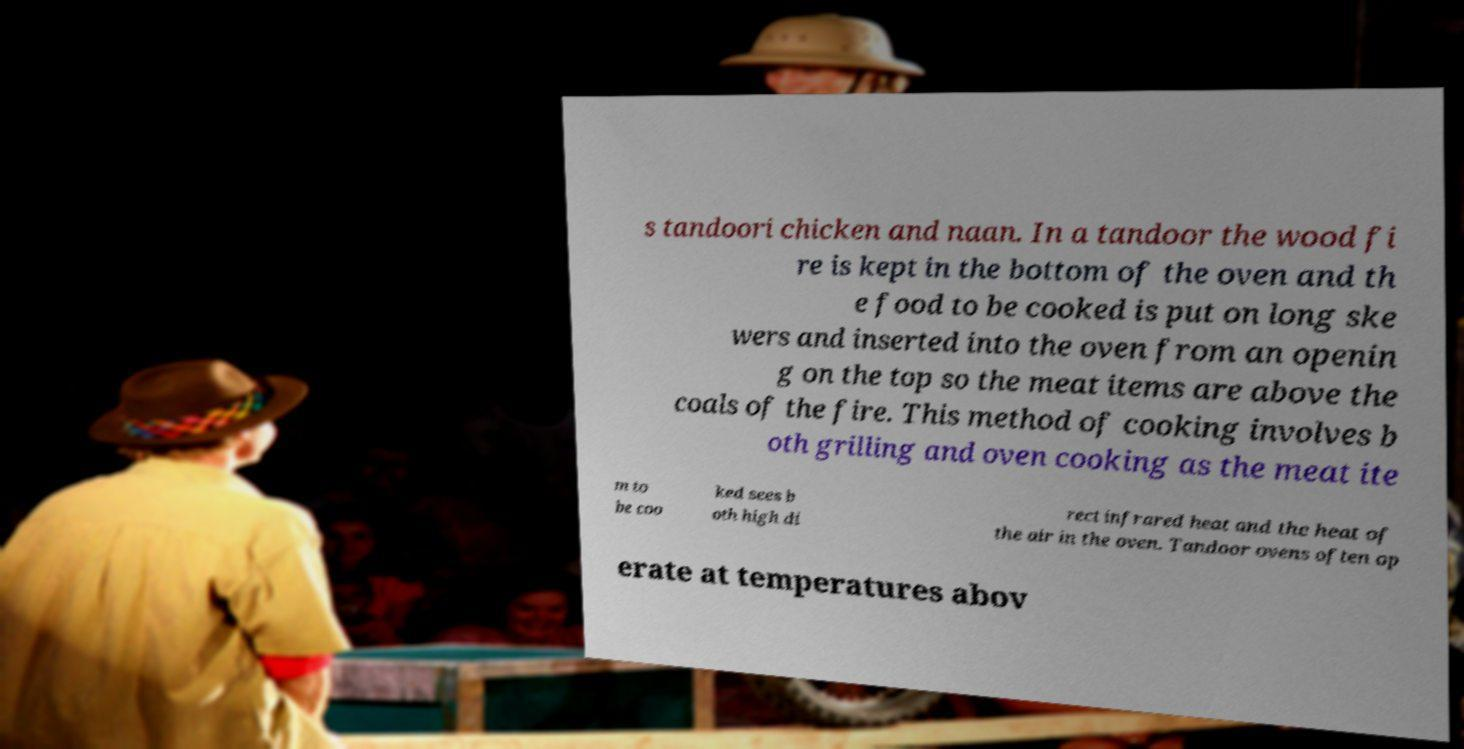There's text embedded in this image that I need extracted. Can you transcribe it verbatim? s tandoori chicken and naan. In a tandoor the wood fi re is kept in the bottom of the oven and th e food to be cooked is put on long ske wers and inserted into the oven from an openin g on the top so the meat items are above the coals of the fire. This method of cooking involves b oth grilling and oven cooking as the meat ite m to be coo ked sees b oth high di rect infrared heat and the heat of the air in the oven. Tandoor ovens often op erate at temperatures abov 